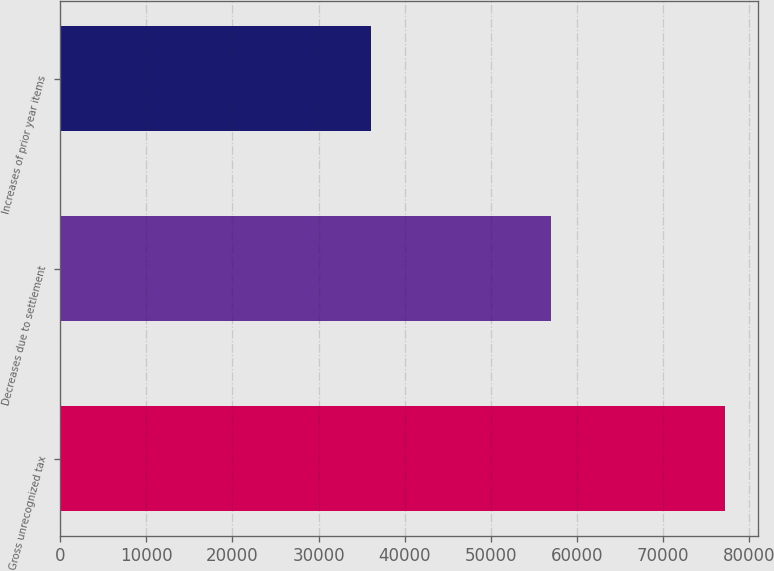Convert chart. <chart><loc_0><loc_0><loc_500><loc_500><bar_chart><fcel>Gross unrecognized tax<fcel>Decreases due to settlement<fcel>Increases of prior year items<nl><fcel>77211<fcel>57022<fcel>36061<nl></chart> 